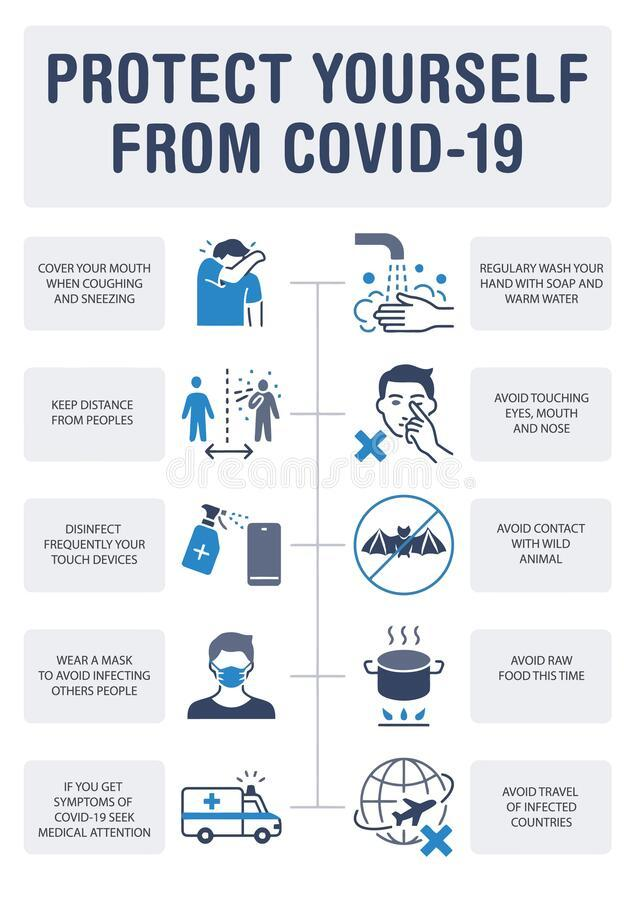Draw attention to some important aspects in this diagram. The infographic features people wearing masks, with a count ranging from 1 to... 